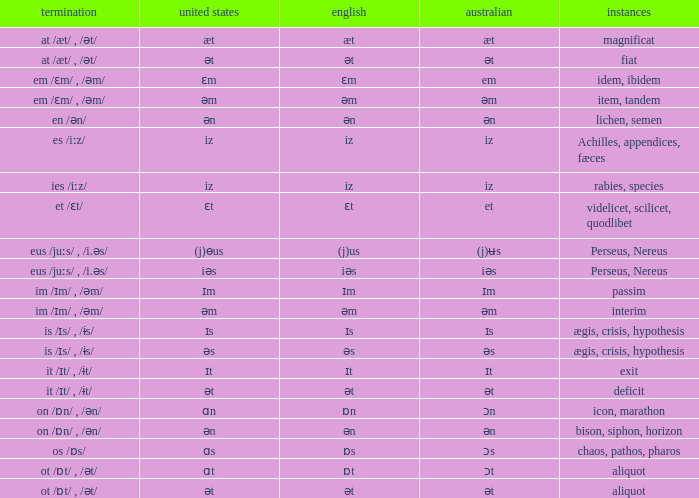Which Examples has Australian of əm? Item, tandem, interim. 